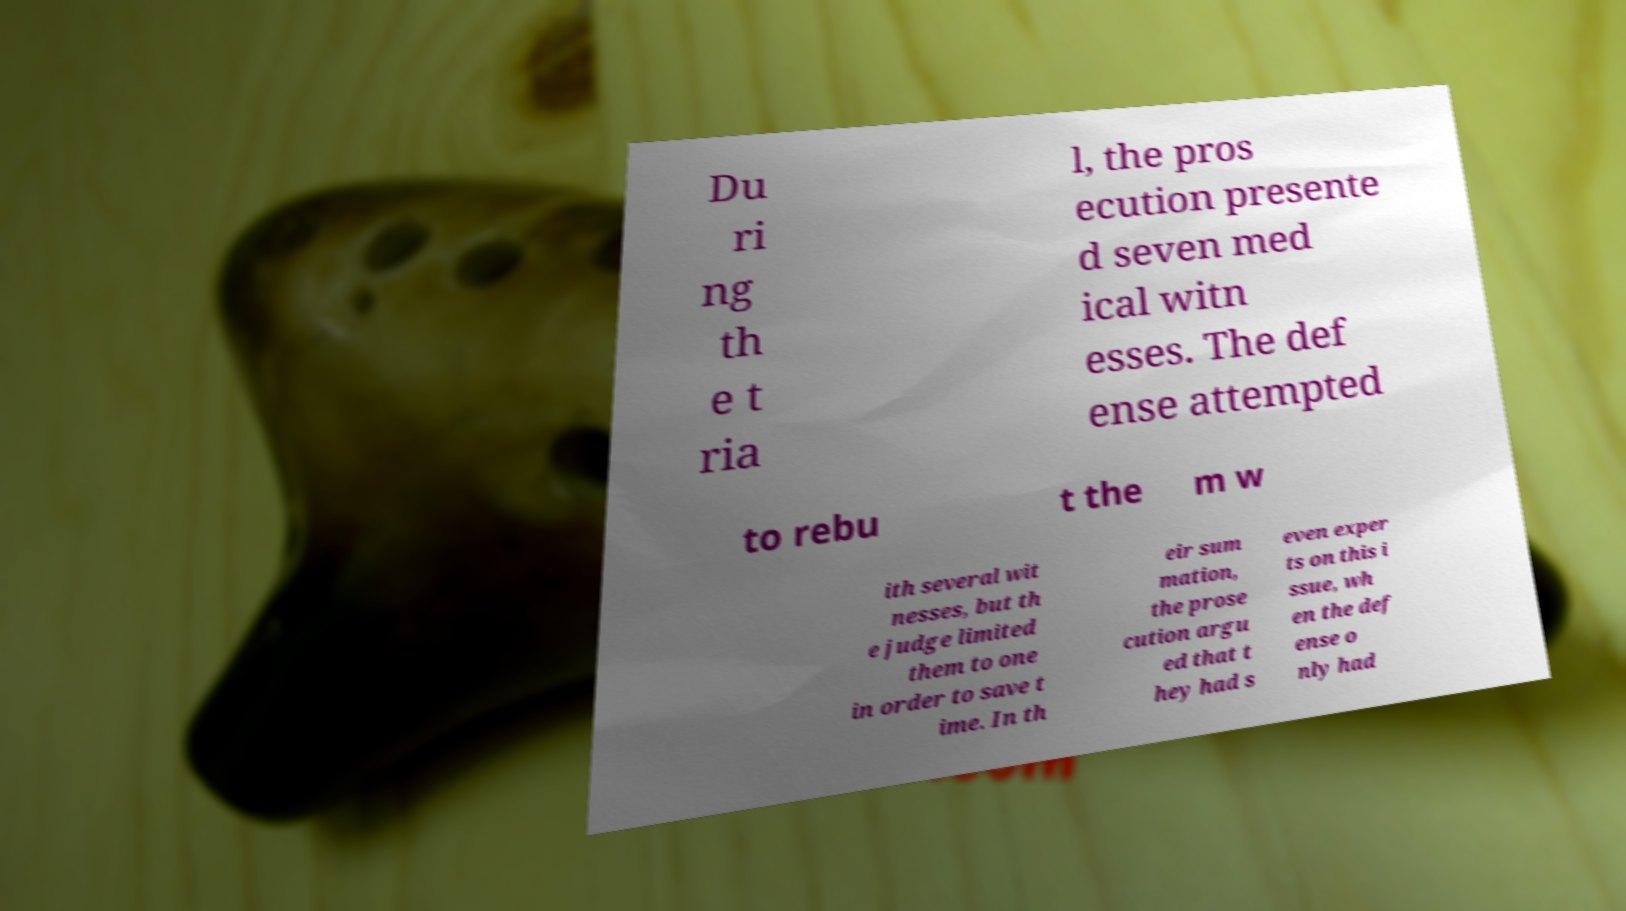What messages or text are displayed in this image? I need them in a readable, typed format. Du ri ng th e t ria l, the pros ecution presente d seven med ical witn esses. The def ense attempted to rebu t the m w ith several wit nesses, but th e judge limited them to one in order to save t ime. In th eir sum mation, the prose cution argu ed that t hey had s even exper ts on this i ssue, wh en the def ense o nly had 